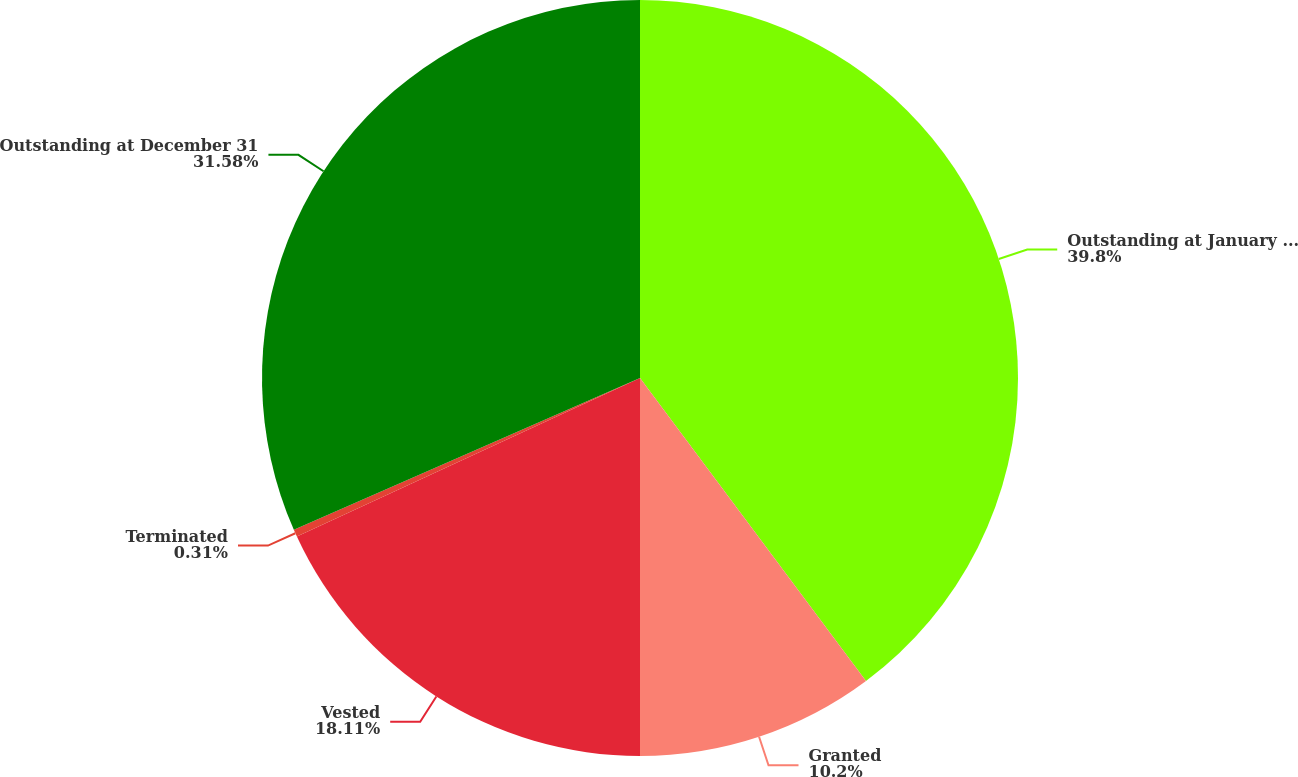Convert chart to OTSL. <chart><loc_0><loc_0><loc_500><loc_500><pie_chart><fcel>Outstanding at January 1 2007<fcel>Granted<fcel>Vested<fcel>Terminated<fcel>Outstanding at December 31<nl><fcel>39.8%<fcel>10.2%<fcel>18.11%<fcel>0.31%<fcel>31.58%<nl></chart> 